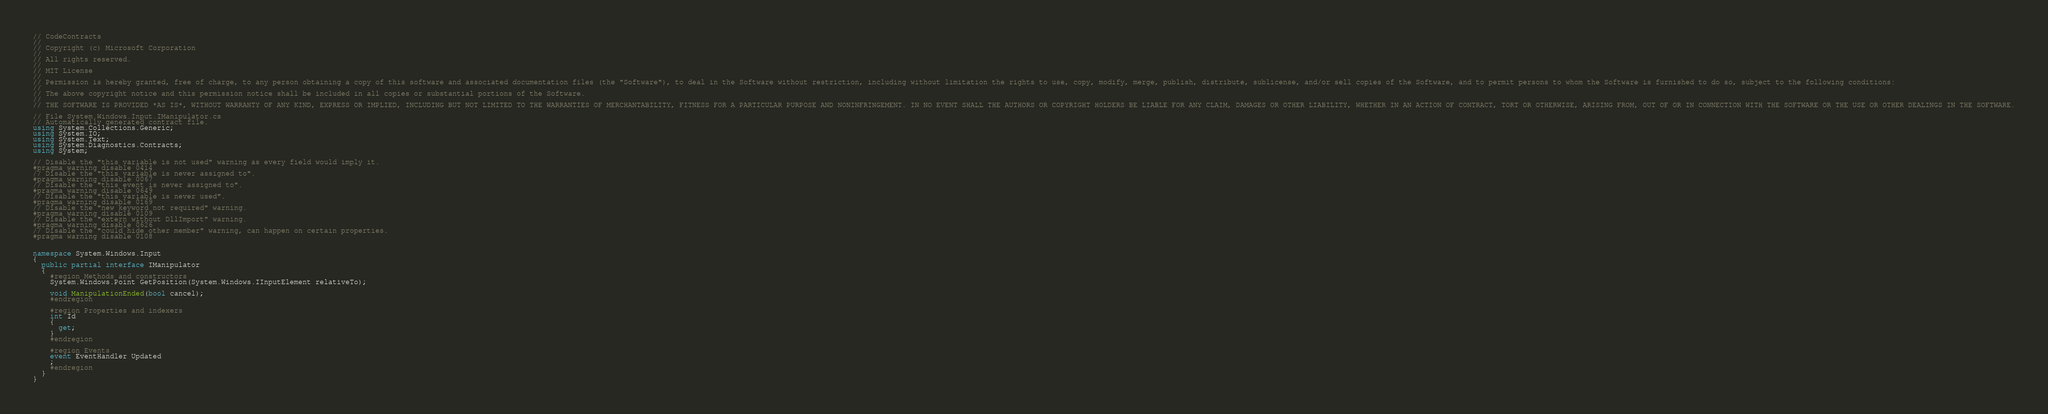Convert code to text. <code><loc_0><loc_0><loc_500><loc_500><_C#_>// CodeContracts
// 
// Copyright (c) Microsoft Corporation
// 
// All rights reserved. 
// 
// MIT License
// 
// Permission is hereby granted, free of charge, to any person obtaining a copy of this software and associated documentation files (the "Software"), to deal in the Software without restriction, including without limitation the rights to use, copy, modify, merge, publish, distribute, sublicense, and/or sell copies of the Software, and to permit persons to whom the Software is furnished to do so, subject to the following conditions:
// 
// The above copyright notice and this permission notice shall be included in all copies or substantial portions of the Software.
// 
// THE SOFTWARE IS PROVIDED *AS IS*, WITHOUT WARRANTY OF ANY KIND, EXPRESS OR IMPLIED, INCLUDING BUT NOT LIMITED TO THE WARRANTIES OF MERCHANTABILITY, FITNESS FOR A PARTICULAR PURPOSE AND NONINFRINGEMENT. IN NO EVENT SHALL THE AUTHORS OR COPYRIGHT HOLDERS BE LIABLE FOR ANY CLAIM, DAMAGES OR OTHER LIABILITY, WHETHER IN AN ACTION OF CONTRACT, TORT OR OTHERWISE, ARISING FROM, OUT OF OR IN CONNECTION WITH THE SOFTWARE OR THE USE OR OTHER DEALINGS IN THE SOFTWARE.

// File System.Windows.Input.IManipulator.cs
// Automatically generated contract file.
using System.Collections.Generic;
using System.IO;
using System.Text;
using System.Diagnostics.Contracts;
using System;

// Disable the "this variable is not used" warning as every field would imply it.
#pragma warning disable 0414
// Disable the "this variable is never assigned to".
#pragma warning disable 0067
// Disable the "this event is never assigned to".
#pragma warning disable 0649
// Disable the "this variable is never used".
#pragma warning disable 0169
// Disable the "new keyword not required" warning.
#pragma warning disable 0109
// Disable the "extern without DllImport" warning.
#pragma warning disable 0626
// Disable the "could hide other member" warning, can happen on certain properties.
#pragma warning disable 0108


namespace System.Windows.Input
{
  public partial interface IManipulator
  {
    #region Methods and constructors
    System.Windows.Point GetPosition(System.Windows.IInputElement relativeTo);

    void ManipulationEnded(bool cancel);
    #endregion

    #region Properties and indexers
    int Id
    {
      get;
    }
    #endregion

    #region Events
    event EventHandler Updated
    ;
    #endregion
  }
}
</code> 